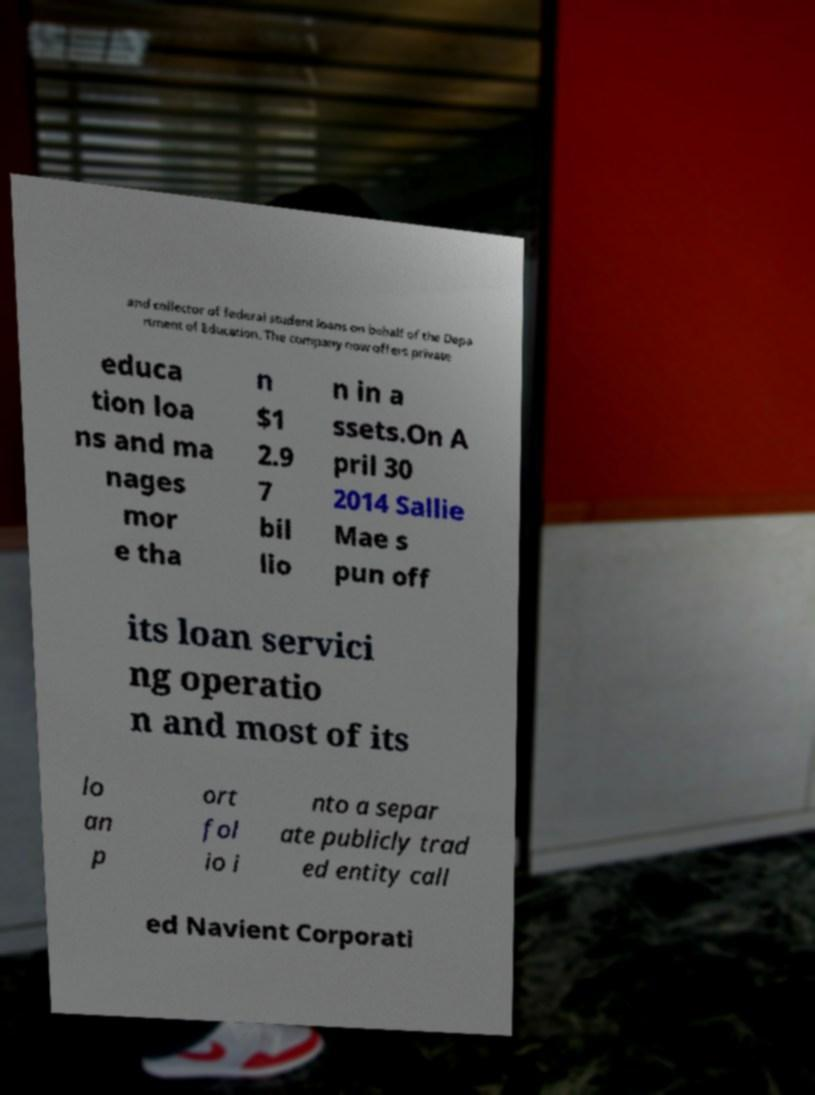Please identify and transcribe the text found in this image. and collector of federal student loans on behalf of the Depa rtment of Education. The company now offers private educa tion loa ns and ma nages mor e tha n $1 2.9 7 bil lio n in a ssets.On A pril 30 2014 Sallie Mae s pun off its loan servici ng operatio n and most of its lo an p ort fol io i nto a separ ate publicly trad ed entity call ed Navient Corporati 